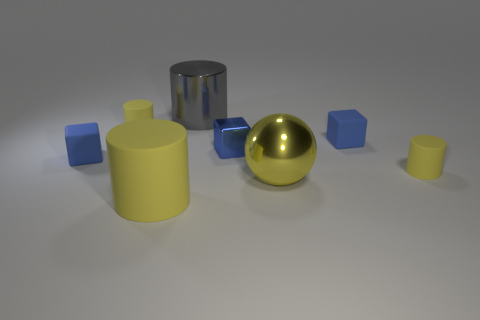Subtract all yellow cylinders. How many were subtracted if there are1yellow cylinders left? 2 Subtract all cyan cubes. How many yellow cylinders are left? 3 Subtract 1 cylinders. How many cylinders are left? 3 Add 2 yellow rubber things. How many objects exist? 10 Subtract all spheres. How many objects are left? 7 Add 2 tiny rubber things. How many tiny rubber things exist? 6 Subtract 0 red balls. How many objects are left? 8 Subtract all tiny gray cylinders. Subtract all tiny cubes. How many objects are left? 5 Add 8 big gray shiny objects. How many big gray shiny objects are left? 9 